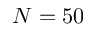<formula> <loc_0><loc_0><loc_500><loc_500>N = 5 0</formula> 